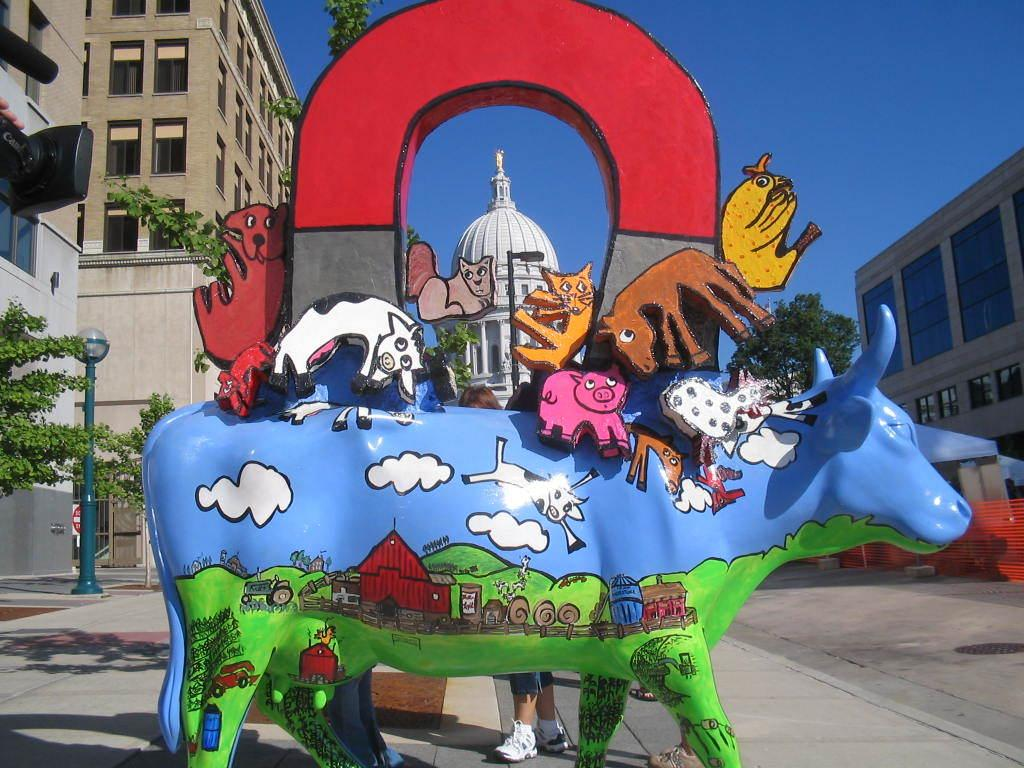What is the main subject in the center of the image? There is a sculpture in the center of the image. What can be seen in the background of the image? There are buildings, trees, a pole, and the sky visible in the background of the image. What is at the bottom of the image? There is a road at the bottom of the image. Can you tell me how many thumbs the sculpture has in the image? The sculpture in the image does not have any thumbs, as it is not a human figure. 